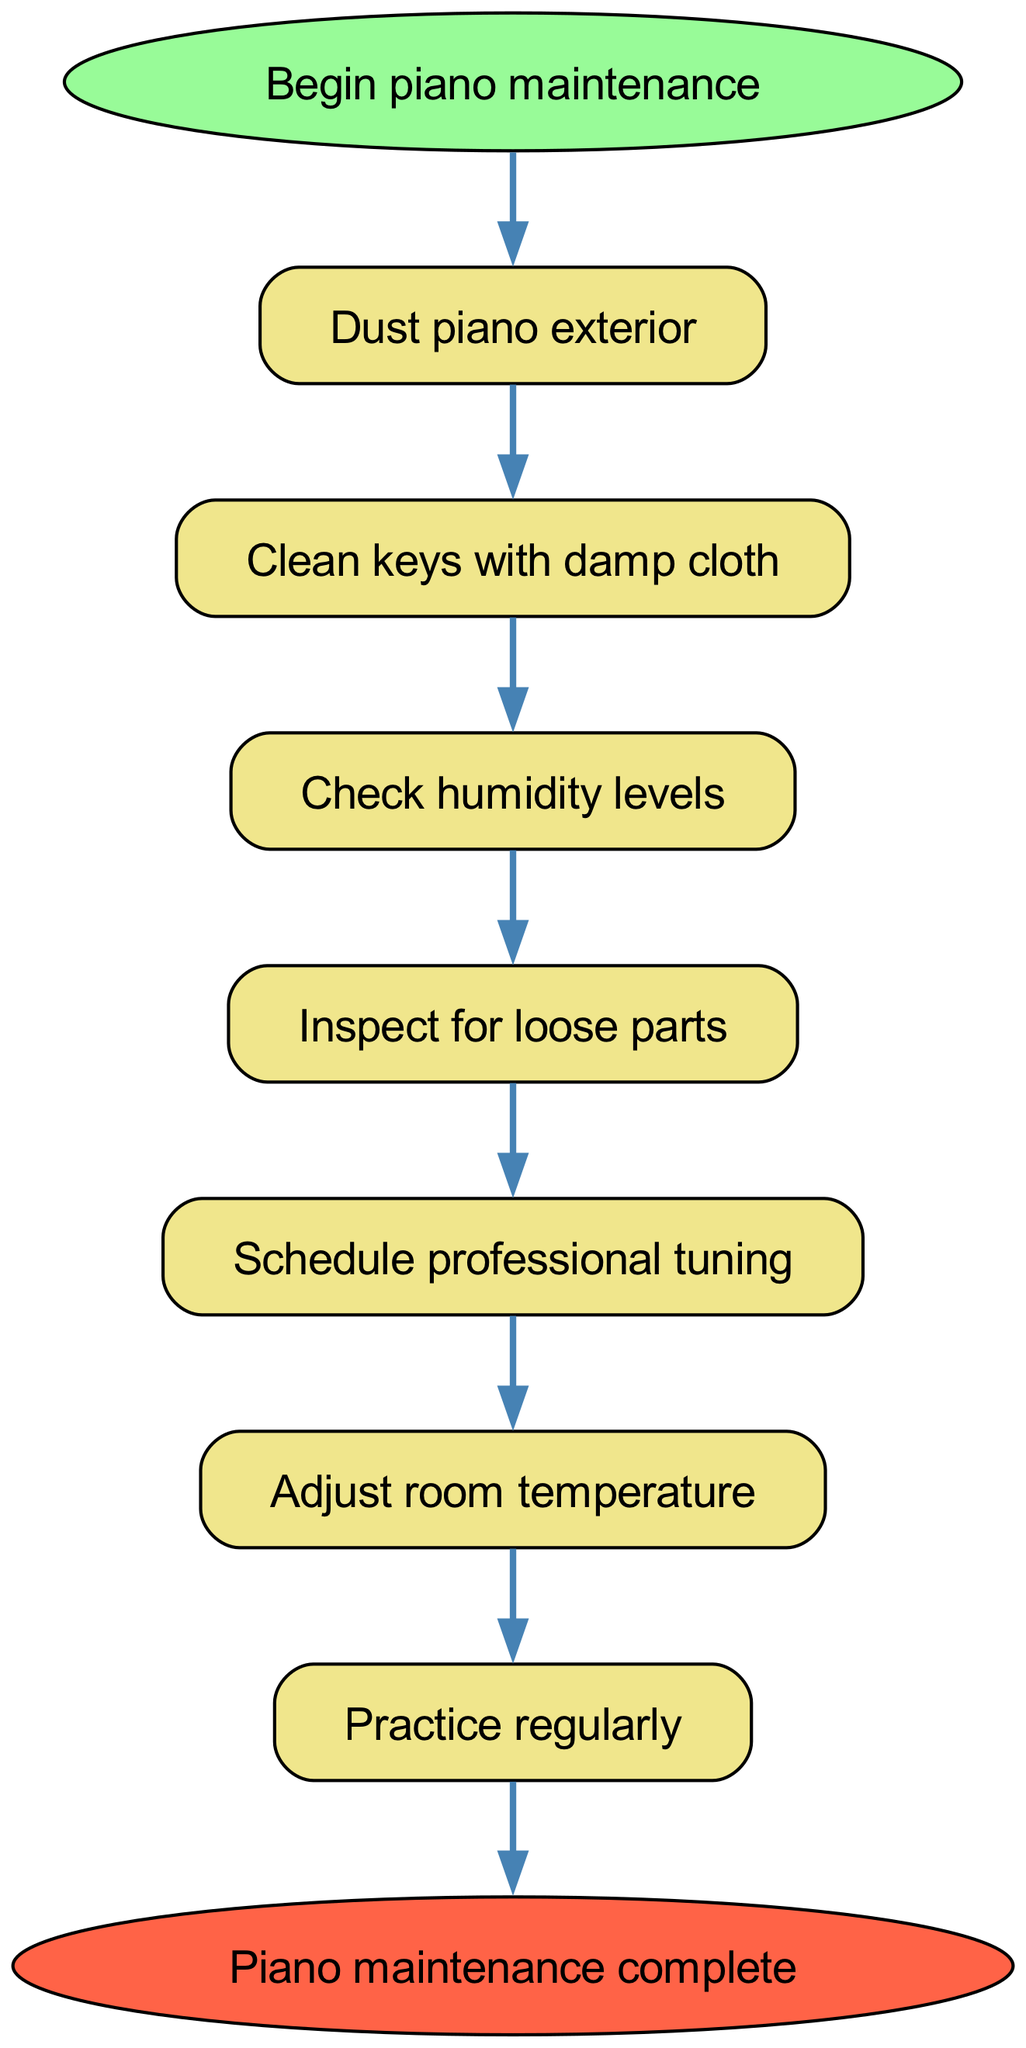What is the first step in piano maintenance? The flow chart begins with the step labeled "Dust piano exterior." This is the initial action to be taken in the maintenance process.
Answer: Dust piano exterior How many steps are there in total? The diagram lists a total of seven steps before reaching the end node. Counting both the start and end node would total nine nodes. However, the focus here is strictly on the steps for maintenance, which are seven.
Answer: Seven What is the last step before the maintenance is complete? From the flow chart, "Practice regularly" is identified as the final maintenance step before concluding the process.
Answer: Practice regularly What action follows "Inspect for loose parts"? The sequence continues from "Inspect for loose parts" with "Schedule professional tuning" as the next step. This establishes a direct link in the flow process.
Answer: Schedule professional tuning Is there a step that requires adjusting room temperature? Yes, the flow chart specifies that after scheduling professional tuning, the next step is "Adjust room temperature," highlighting a necessary action for tuning conditions.
Answer: Adjust room temperature Which maintenance step involves cleaning? The flow chart outlines "Clean keys with damp cloth" as the maintenance step that specifically pertains to cleaning, focusing on the piano keys.
Answer: Clean keys with damp cloth What action is taken if humidity levels need to be checked? Upon reaching the step "Check humidity levels," if adjustments are deemed necessary, it leads to the next action, which is to "Inspect for loose parts", indicating a continuation of maintenance measures.
Answer: Inspect for loose parts What indicates the completion of the piano maintenance process? The conclusion of the maintenance process is signified by the node labeled "Piano maintenance complete," marking the endpoint of the instructions diagram.
Answer: Piano maintenance complete 